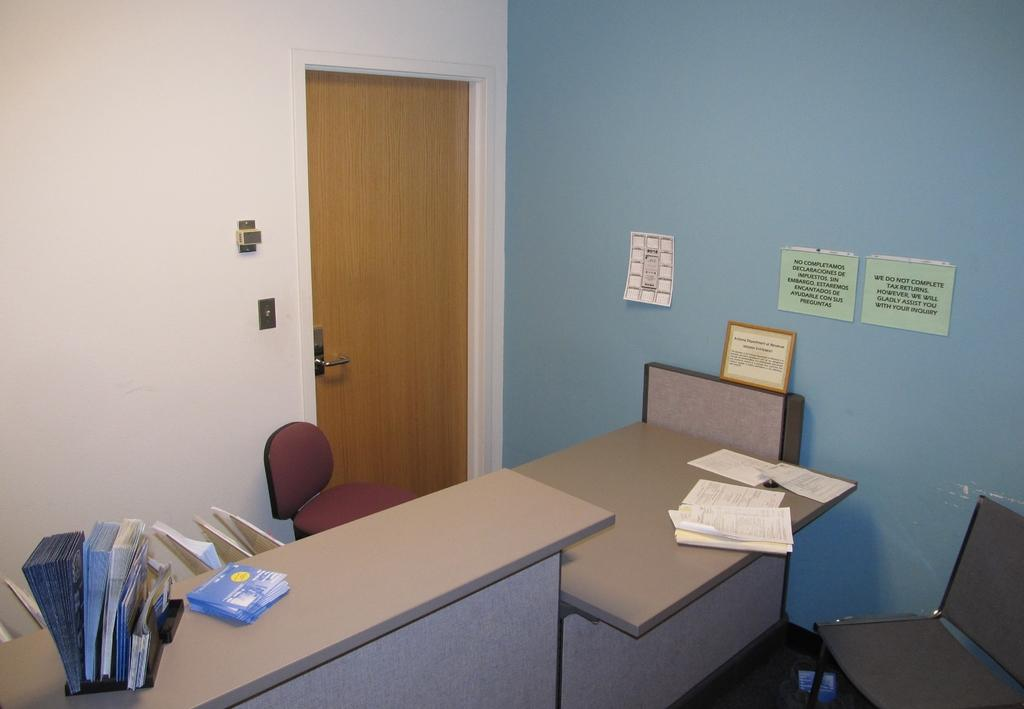What is on the tables in the image? There are papers and pamphlets in a stand on the tables. What type of furniture is present in the image? There are chairs in the image. What is attached to the wall in the image? Papers are stuck to the wall. What type of decorative item can be seen in the image? There is a frame in the image. What is the main feature of the door in the image? The door has a door handle. What part of the room is visible in the image? The wall is visible in the image. What type of story is being told by the dinosaurs in the image? There are no dinosaurs present in the image; the image features papers, pamphlets, chairs, a frame, a door, and a wall. 